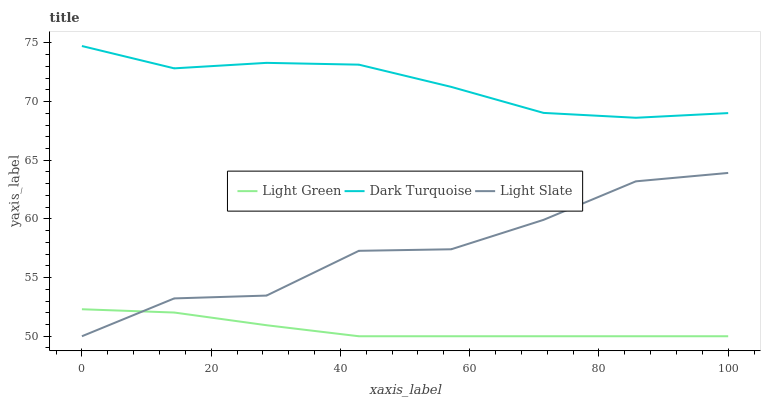Does Light Green have the minimum area under the curve?
Answer yes or no. Yes. Does Dark Turquoise have the maximum area under the curve?
Answer yes or no. Yes. Does Dark Turquoise have the minimum area under the curve?
Answer yes or no. No. Does Light Green have the maximum area under the curve?
Answer yes or no. No. Is Light Green the smoothest?
Answer yes or no. Yes. Is Light Slate the roughest?
Answer yes or no. Yes. Is Dark Turquoise the smoothest?
Answer yes or no. No. Is Dark Turquoise the roughest?
Answer yes or no. No. Does Light Slate have the lowest value?
Answer yes or no. Yes. Does Dark Turquoise have the lowest value?
Answer yes or no. No. Does Dark Turquoise have the highest value?
Answer yes or no. Yes. Does Light Green have the highest value?
Answer yes or no. No. Is Light Slate less than Dark Turquoise?
Answer yes or no. Yes. Is Dark Turquoise greater than Light Slate?
Answer yes or no. Yes. Does Light Slate intersect Light Green?
Answer yes or no. Yes. Is Light Slate less than Light Green?
Answer yes or no. No. Is Light Slate greater than Light Green?
Answer yes or no. No. Does Light Slate intersect Dark Turquoise?
Answer yes or no. No. 